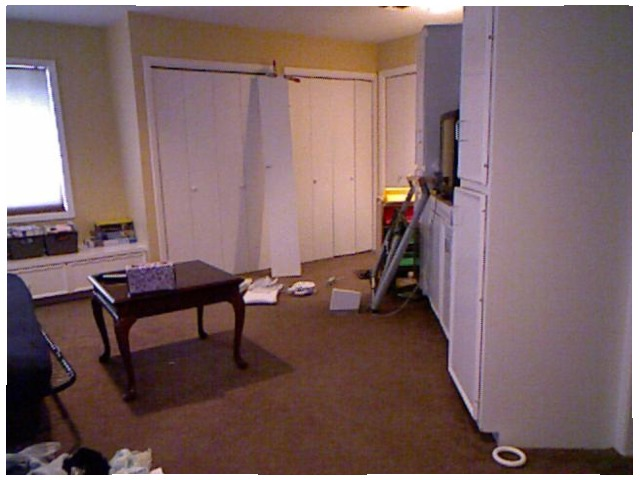<image>
Is there a table to the left of the gift box? No. The table is not to the left of the gift box. From this viewpoint, they have a different horizontal relationship. 